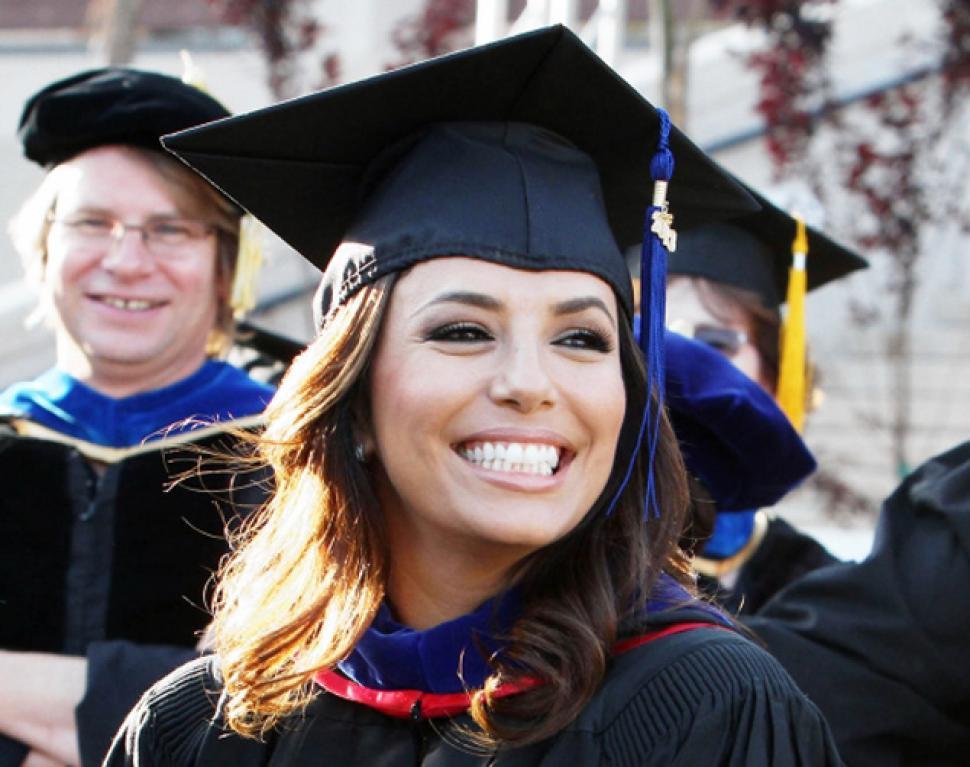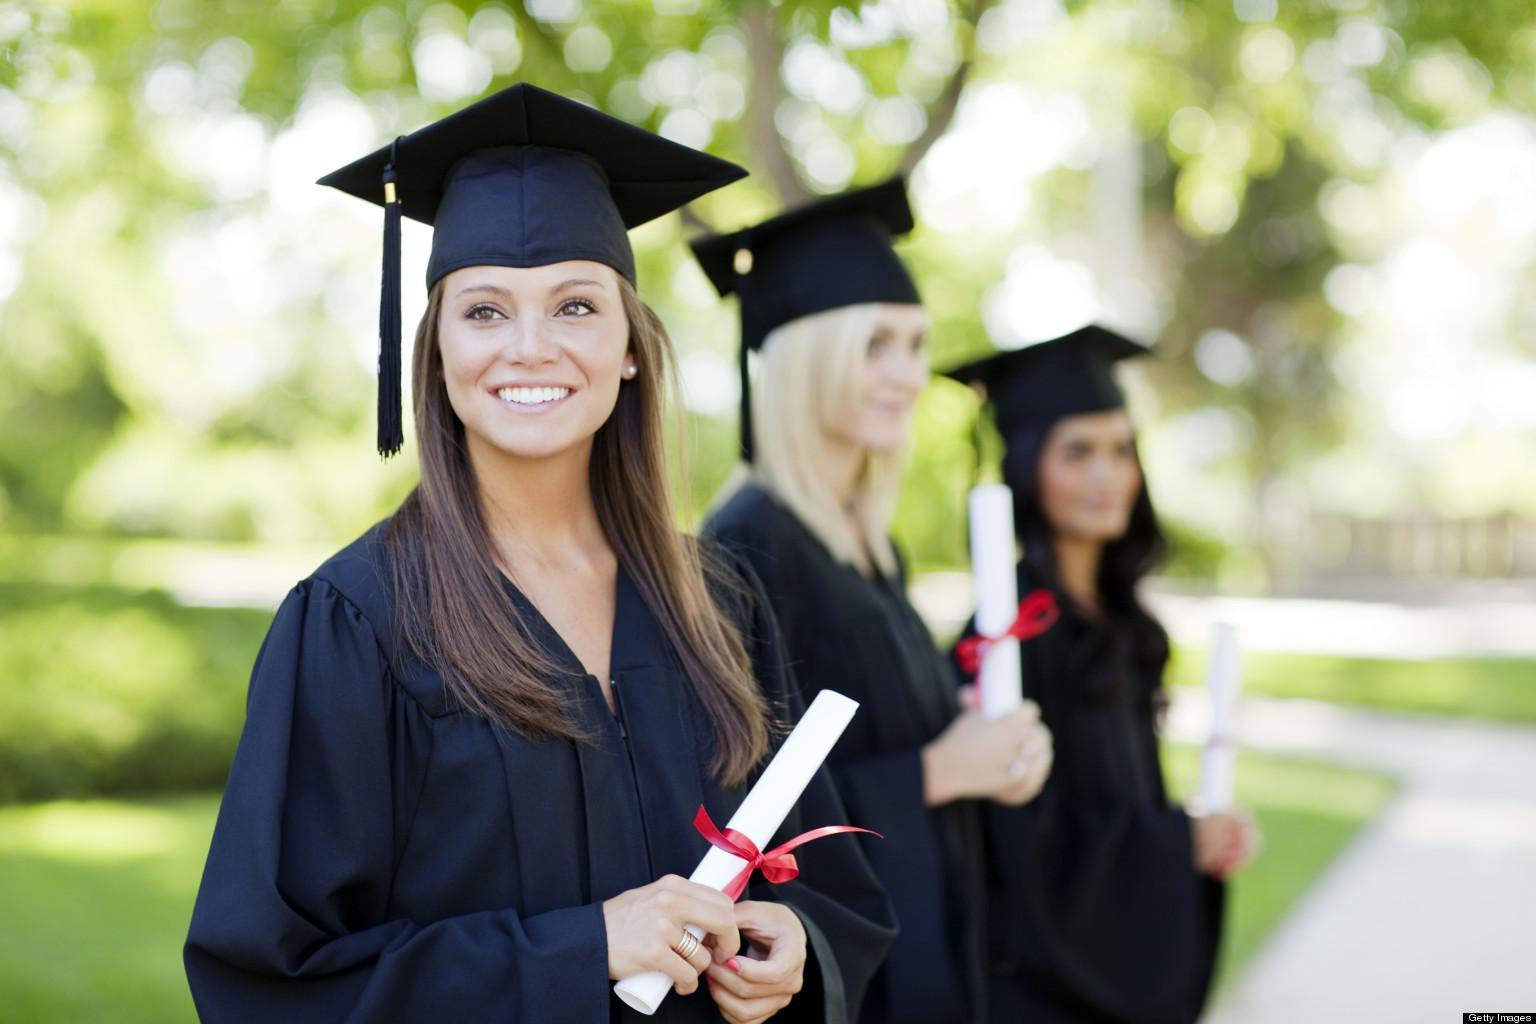The first image is the image on the left, the second image is the image on the right. For the images shown, is this caption "An image shows a nonwhite male graduate standing on the left and a white female standing on the right." true? Answer yes or no. No. 